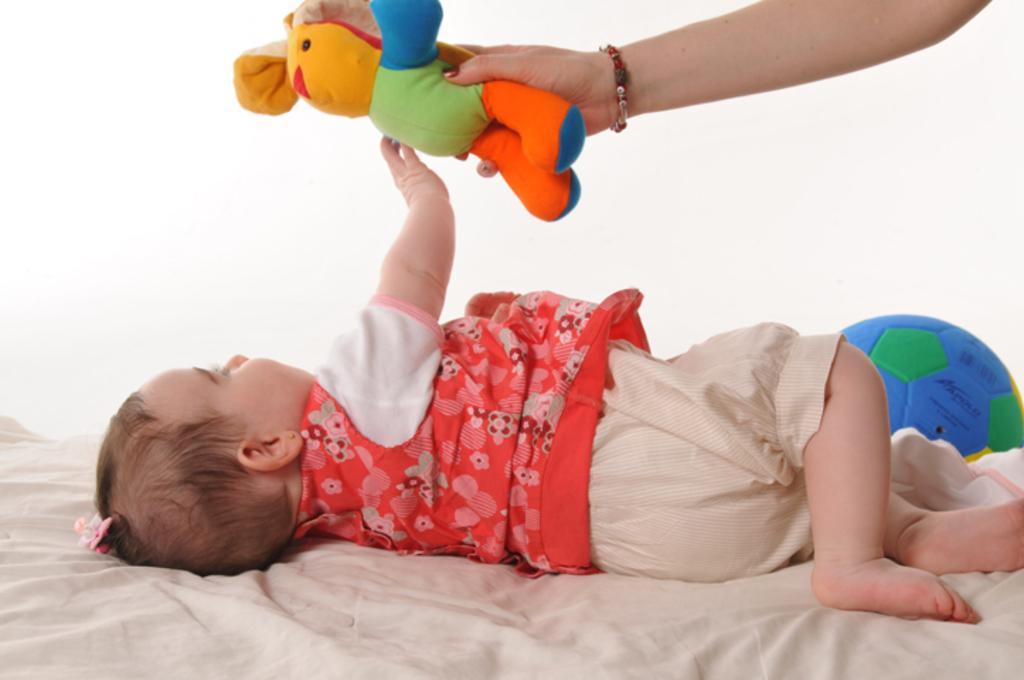Can you describe this image briefly? In this image I can see a baby, who is wearing a red colored t-shirt and cream colored shorts and lying on the bed. I can see that there is a ball near the baby. I can also see that there is a hand holding the soft toy and showing it to the baby. 